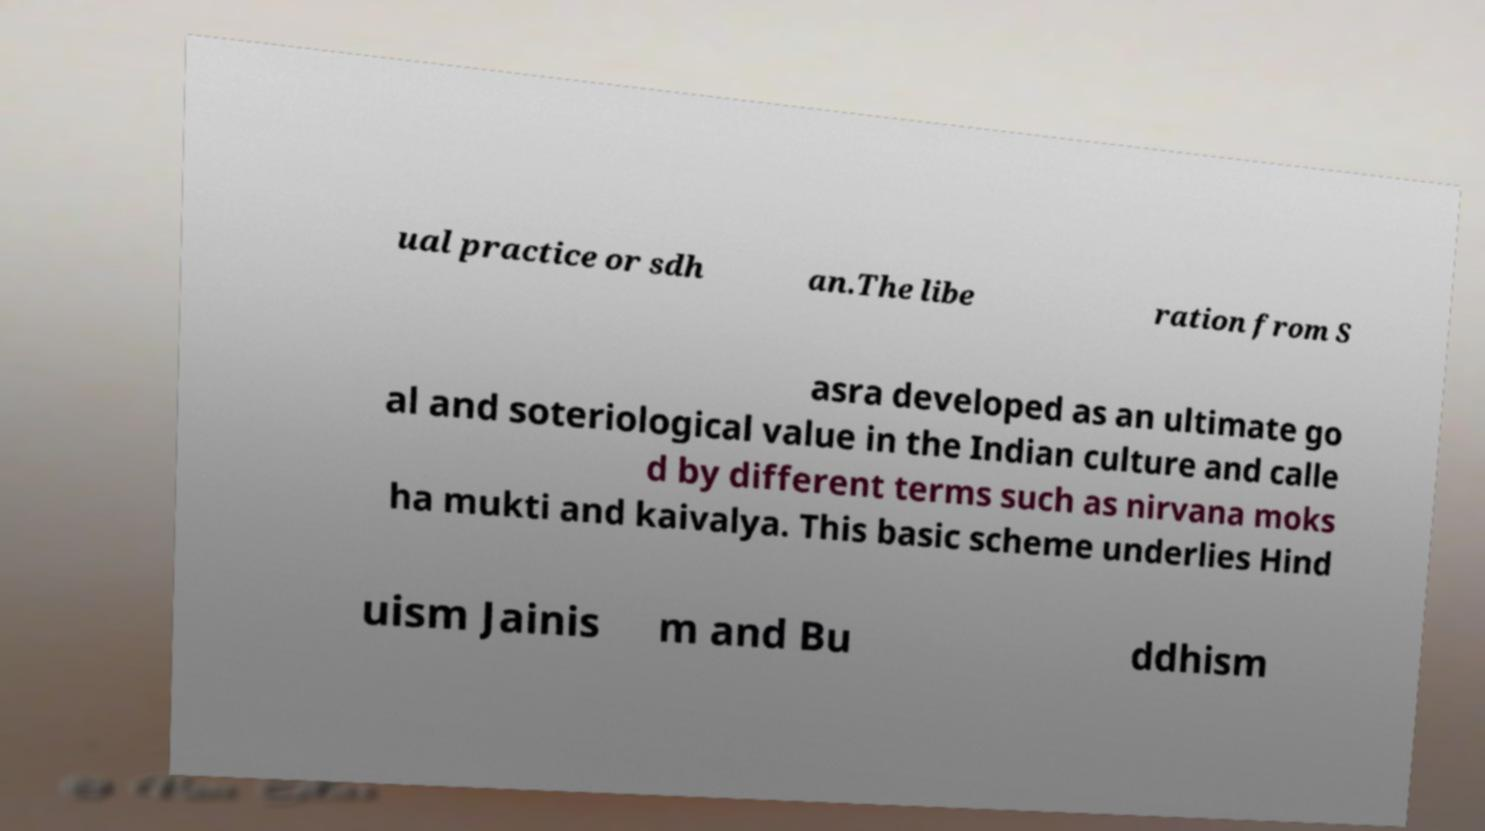Could you assist in decoding the text presented in this image and type it out clearly? ual practice or sdh an.The libe ration from S asra developed as an ultimate go al and soteriological value in the Indian culture and calle d by different terms such as nirvana moks ha mukti and kaivalya. This basic scheme underlies Hind uism Jainis m and Bu ddhism 